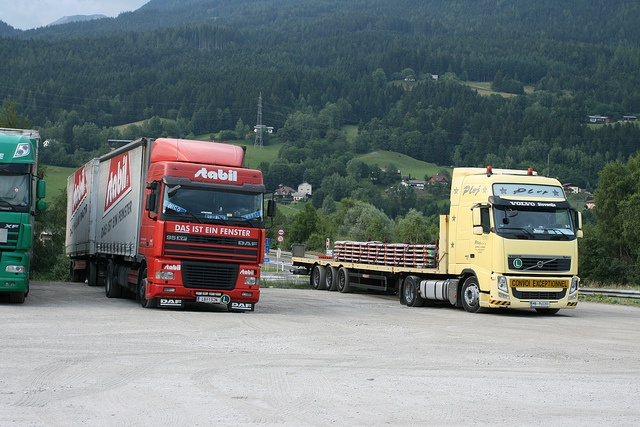Describe the objects in this image and their specific colors. I can see truck in lightblue, black, gray, darkgray, and brown tones, truck in lightblue, black, khaki, gray, and beige tones, truck in lightblue, black, teal, gray, and darkgreen tones, and stop sign in lightblue, gray, darkgray, darkgreen, and lightgray tones in this image. 